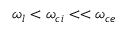Convert formula to latex. <formula><loc_0><loc_0><loc_500><loc_500>\omega _ { l } < \omega _ { c i } < < \omega _ { c e }</formula> 